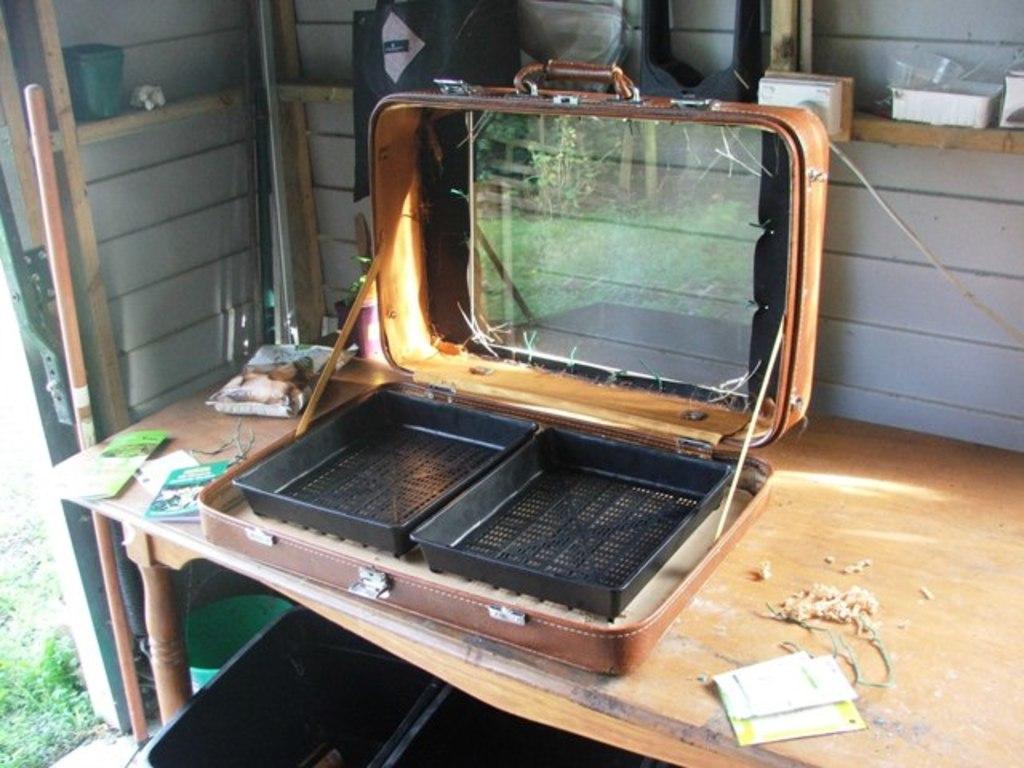In one or two sentences, can you explain what this image depicts? In a picture there is a table, on the table there is one suitcase in that one mirror is there and two trays are there, on the table some papers and one packet is there, behind the table there is a wall on which some cups and some bowl is present and outside the wall there is grass. 